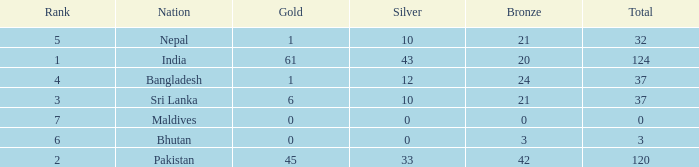Which Gold has a Nation of sri lanka, and a Silver smaller than 10? None. 